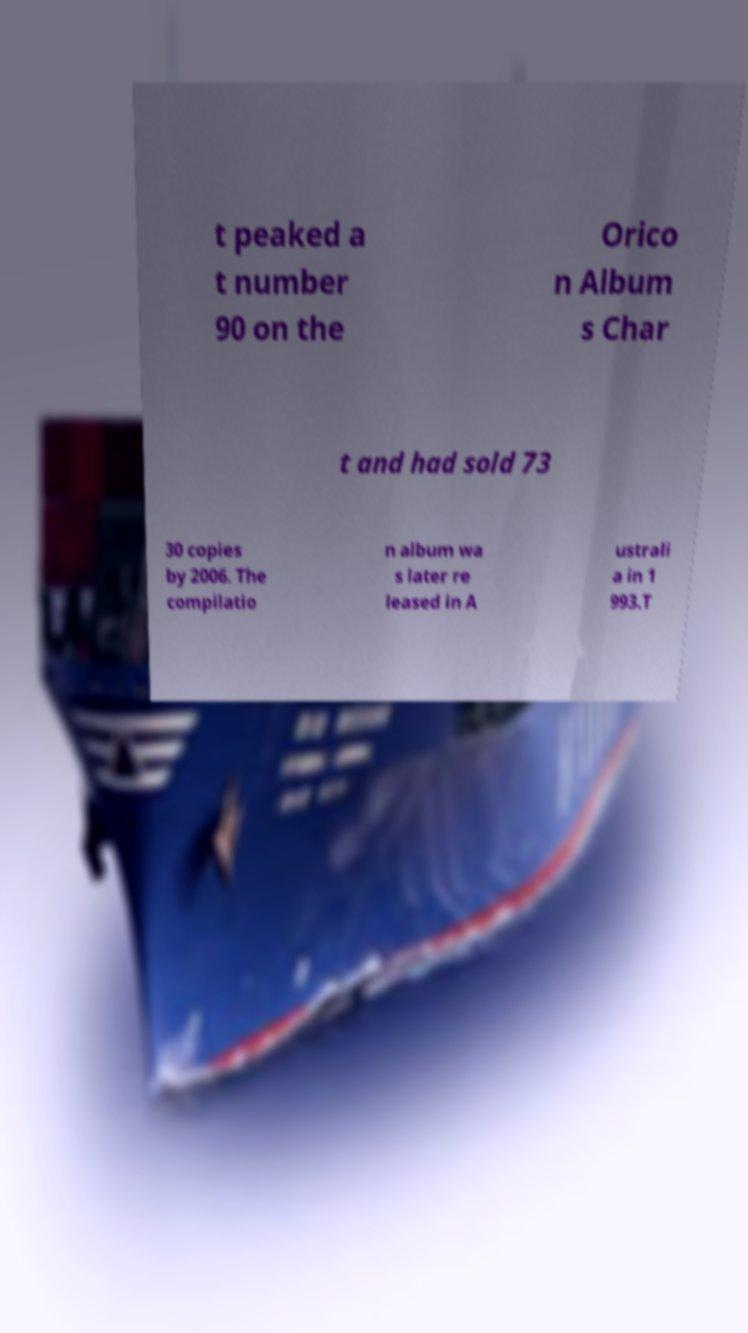Please read and relay the text visible in this image. What does it say? t peaked a t number 90 on the Orico n Album s Char t and had sold 73 30 copies by 2006. The compilatio n album wa s later re leased in A ustrali a in 1 993.T 